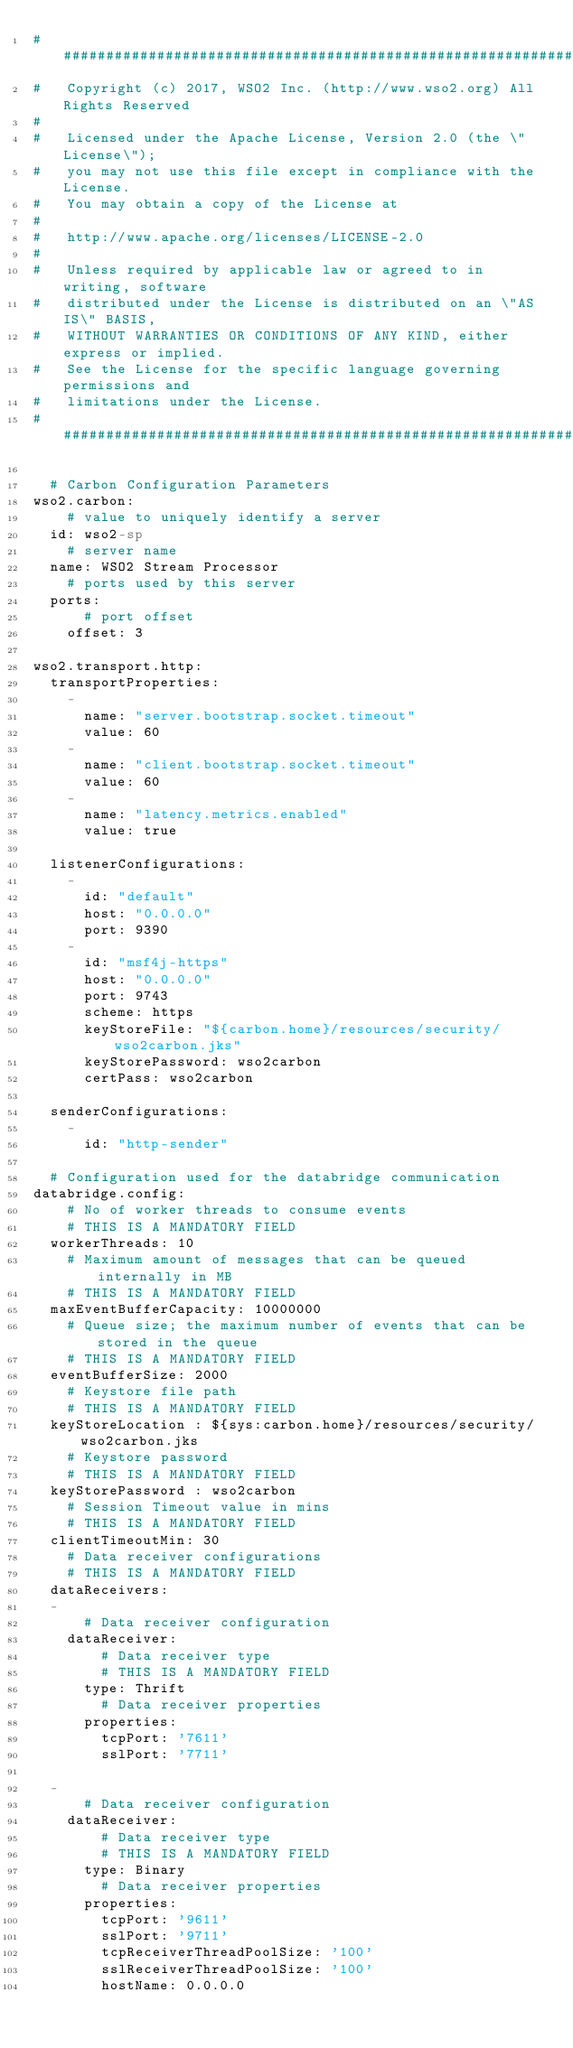<code> <loc_0><loc_0><loc_500><loc_500><_YAML_>################################################################################
#   Copyright (c) 2017, WSO2 Inc. (http://www.wso2.org) All Rights Reserved
#
#   Licensed under the Apache License, Version 2.0 (the \"License\");
#   you may not use this file except in compliance with the License.
#   You may obtain a copy of the License at
#
#   http://www.apache.org/licenses/LICENSE-2.0
#
#   Unless required by applicable law or agreed to in writing, software
#   distributed under the License is distributed on an \"AS IS\" BASIS,
#   WITHOUT WARRANTIES OR CONDITIONS OF ANY KIND, either express or implied.
#   See the License for the specific language governing permissions and
#   limitations under the License.
################################################################################

  # Carbon Configuration Parameters
wso2.carbon:
    # value to uniquely identify a server
  id: wso2-sp
    # server name
  name: WSO2 Stream Processor
    # ports used by this server
  ports:
      # port offset
    offset: 3

wso2.transport.http:
  transportProperties:
    -
      name: "server.bootstrap.socket.timeout"
      value: 60
    -
      name: "client.bootstrap.socket.timeout"
      value: 60
    -
      name: "latency.metrics.enabled"
      value: true

  listenerConfigurations:
    -
      id: "default"
      host: "0.0.0.0"
      port: 9390
    -
      id: "msf4j-https"
      host: "0.0.0.0"
      port: 9743
      scheme: https
      keyStoreFile: "${carbon.home}/resources/security/wso2carbon.jks"
      keyStorePassword: wso2carbon
      certPass: wso2carbon

  senderConfigurations:
    -
      id: "http-sender"

  # Configuration used for the databridge communication
databridge.config:
    # No of worker threads to consume events
    # THIS IS A MANDATORY FIELD
  workerThreads: 10
    # Maximum amount of messages that can be queued internally in MB
    # THIS IS A MANDATORY FIELD
  maxEventBufferCapacity: 10000000
    # Queue size; the maximum number of events that can be stored in the queue
    # THIS IS A MANDATORY FIELD
  eventBufferSize: 2000
    # Keystore file path
    # THIS IS A MANDATORY FIELD
  keyStoreLocation : ${sys:carbon.home}/resources/security/wso2carbon.jks
    # Keystore password
    # THIS IS A MANDATORY FIELD
  keyStorePassword : wso2carbon
    # Session Timeout value in mins
    # THIS IS A MANDATORY FIELD
  clientTimeoutMin: 30
    # Data receiver configurations
    # THIS IS A MANDATORY FIELD
  dataReceivers:
  -
      # Data receiver configuration
    dataReceiver:
        # Data receiver type
        # THIS IS A MANDATORY FIELD
      type: Thrift
        # Data receiver properties
      properties:
        tcpPort: '7611'
        sslPort: '7711'

  -
      # Data receiver configuration
    dataReceiver:
        # Data receiver type
        # THIS IS A MANDATORY FIELD
      type: Binary
        # Data receiver properties
      properties:
        tcpPort: '9611'
        sslPort: '9711'
        tcpReceiverThreadPoolSize: '100'
        sslReceiverThreadPoolSize: '100'
        hostName: 0.0.0.0
</code> 